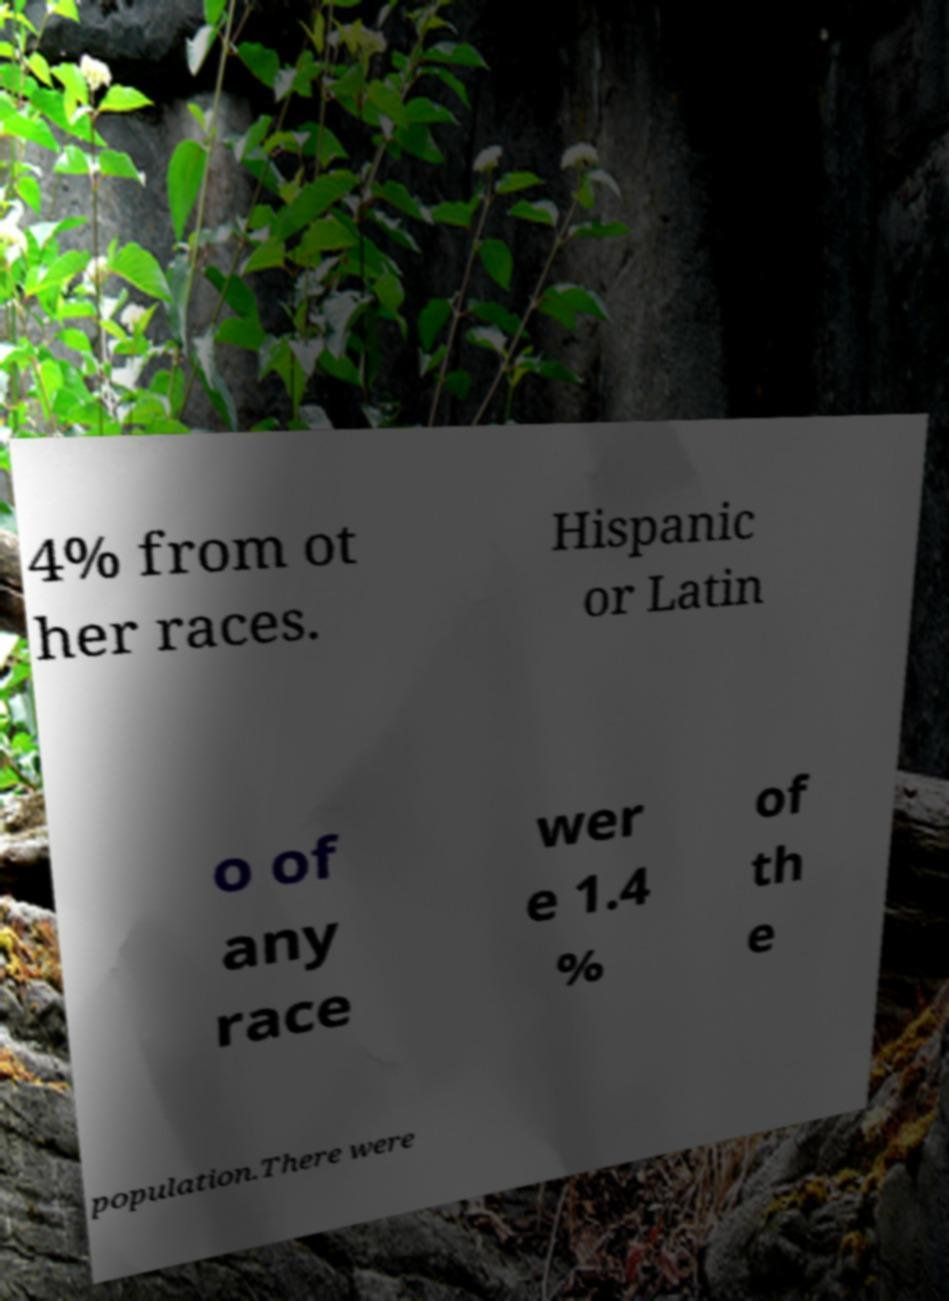What messages or text are displayed in this image? I need them in a readable, typed format. 4% from ot her races. Hispanic or Latin o of any race wer e 1.4 % of th e population.There were 